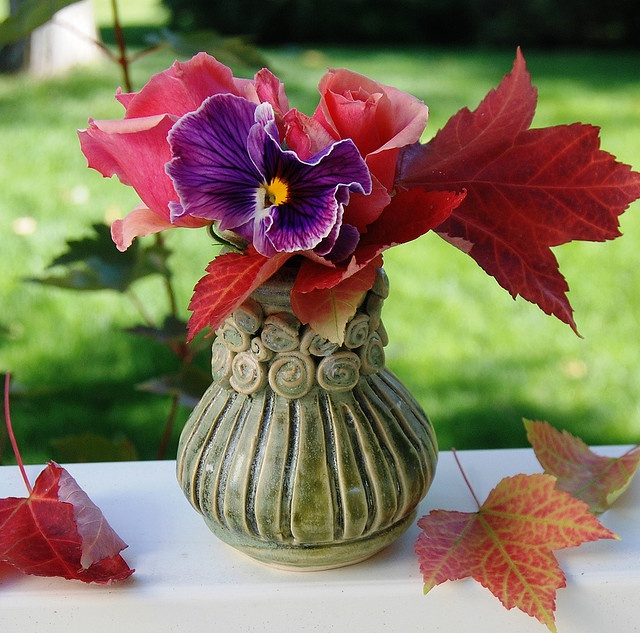Describe the objects in this image and their specific colors. I can see a vase in lightgreen, darkgreen, gray, darkgray, and olive tones in this image. 